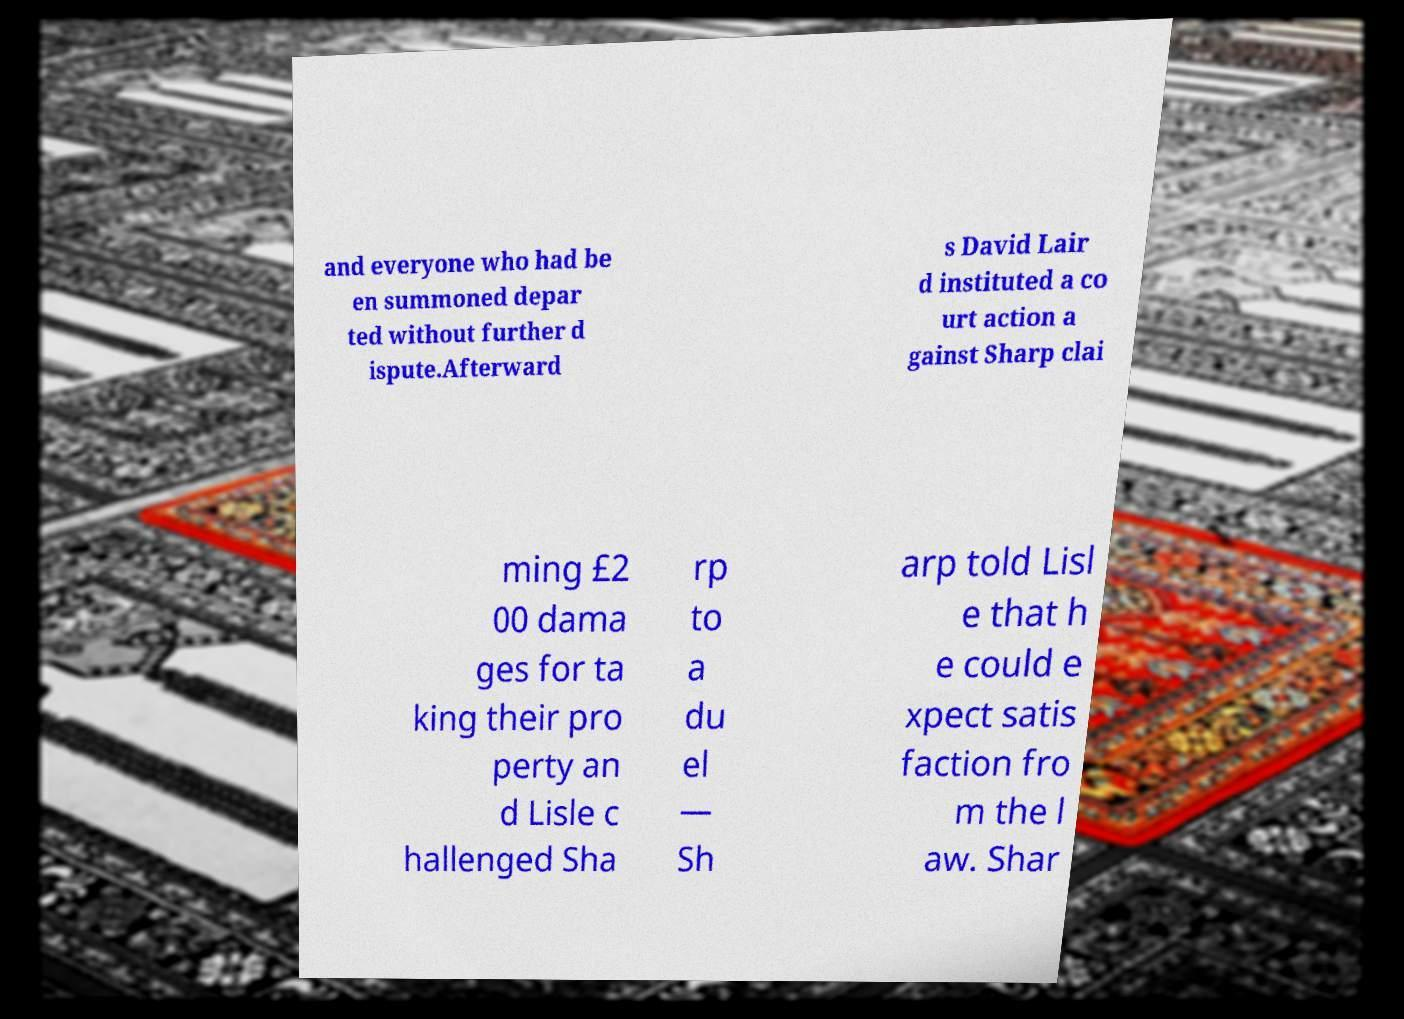Can you read and provide the text displayed in the image?This photo seems to have some interesting text. Can you extract and type it out for me? and everyone who had be en summoned depar ted without further d ispute.Afterward s David Lair d instituted a co urt action a gainst Sharp clai ming £2 00 dama ges for ta king their pro perty an d Lisle c hallenged Sha rp to a du el — Sh arp told Lisl e that h e could e xpect satis faction fro m the l aw. Shar 